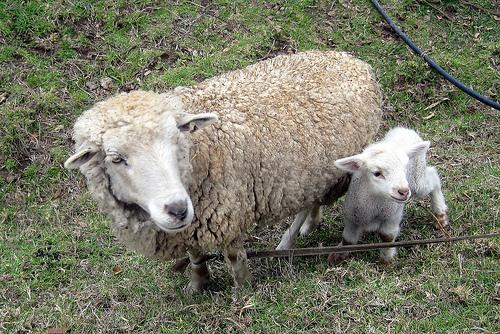Question: who is sitting in the picture?
Choices:
A. Grandma.
B. Grandpa.
C. Child.
D. No one.
Answer with the letter. Answer: D Question: what is the picture showing?
Choices:
A. Farm.
B. Beach.
C. Yard.
D. A sheep and a lamb.
Answer with the letter. Answer: D Question: how many animals are in the picture?
Choices:
A. One.
B. Two.
C. Four.
D. Five.
Answer with the letter. Answer: B Question: where are the animals standing?
Choices:
A. On the farm.
B. Outside.
C. On the grass.
D. Inside.
Answer with the letter. Answer: C 